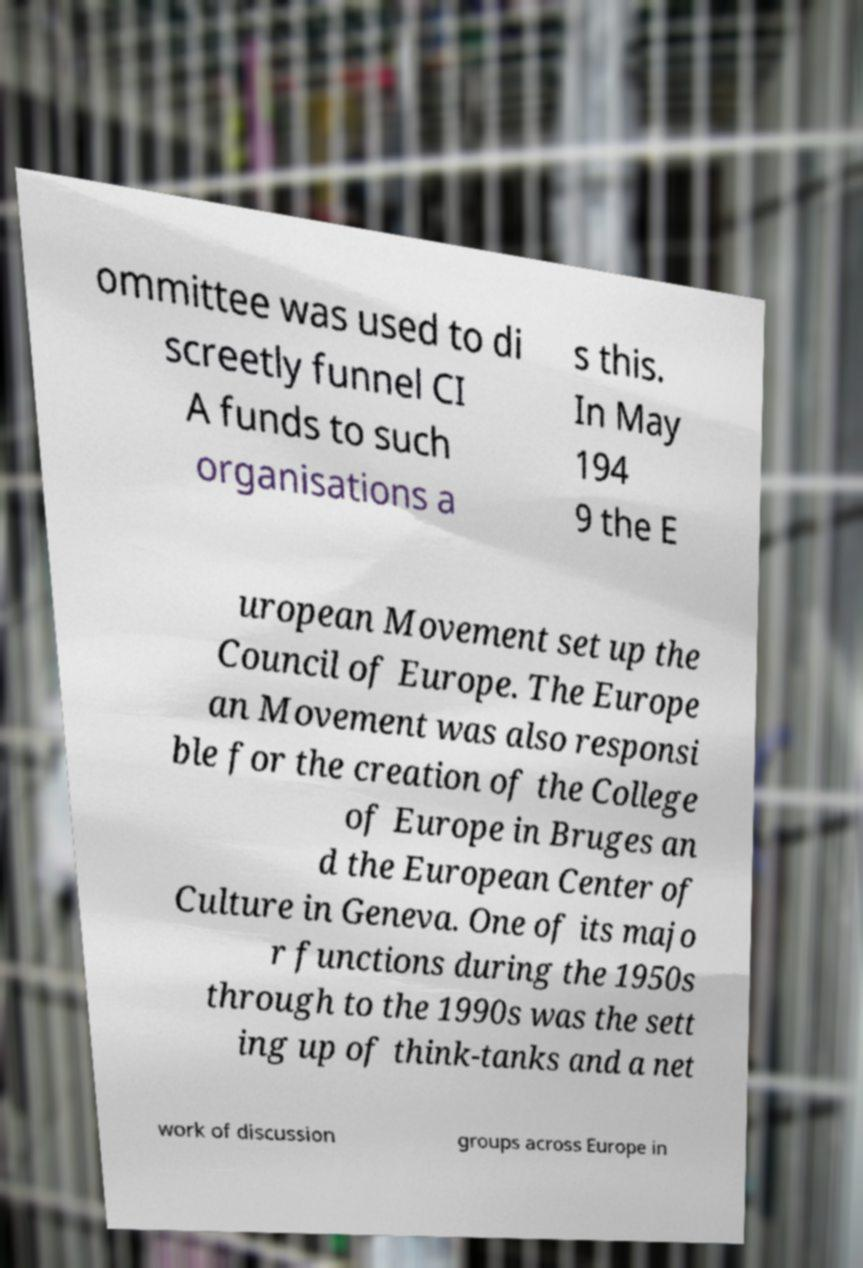Can you accurately transcribe the text from the provided image for me? ommittee was used to di screetly funnel CI A funds to such organisations a s this. In May 194 9 the E uropean Movement set up the Council of Europe. The Europe an Movement was also responsi ble for the creation of the College of Europe in Bruges an d the European Center of Culture in Geneva. One of its majo r functions during the 1950s through to the 1990s was the sett ing up of think-tanks and a net work of discussion groups across Europe in 